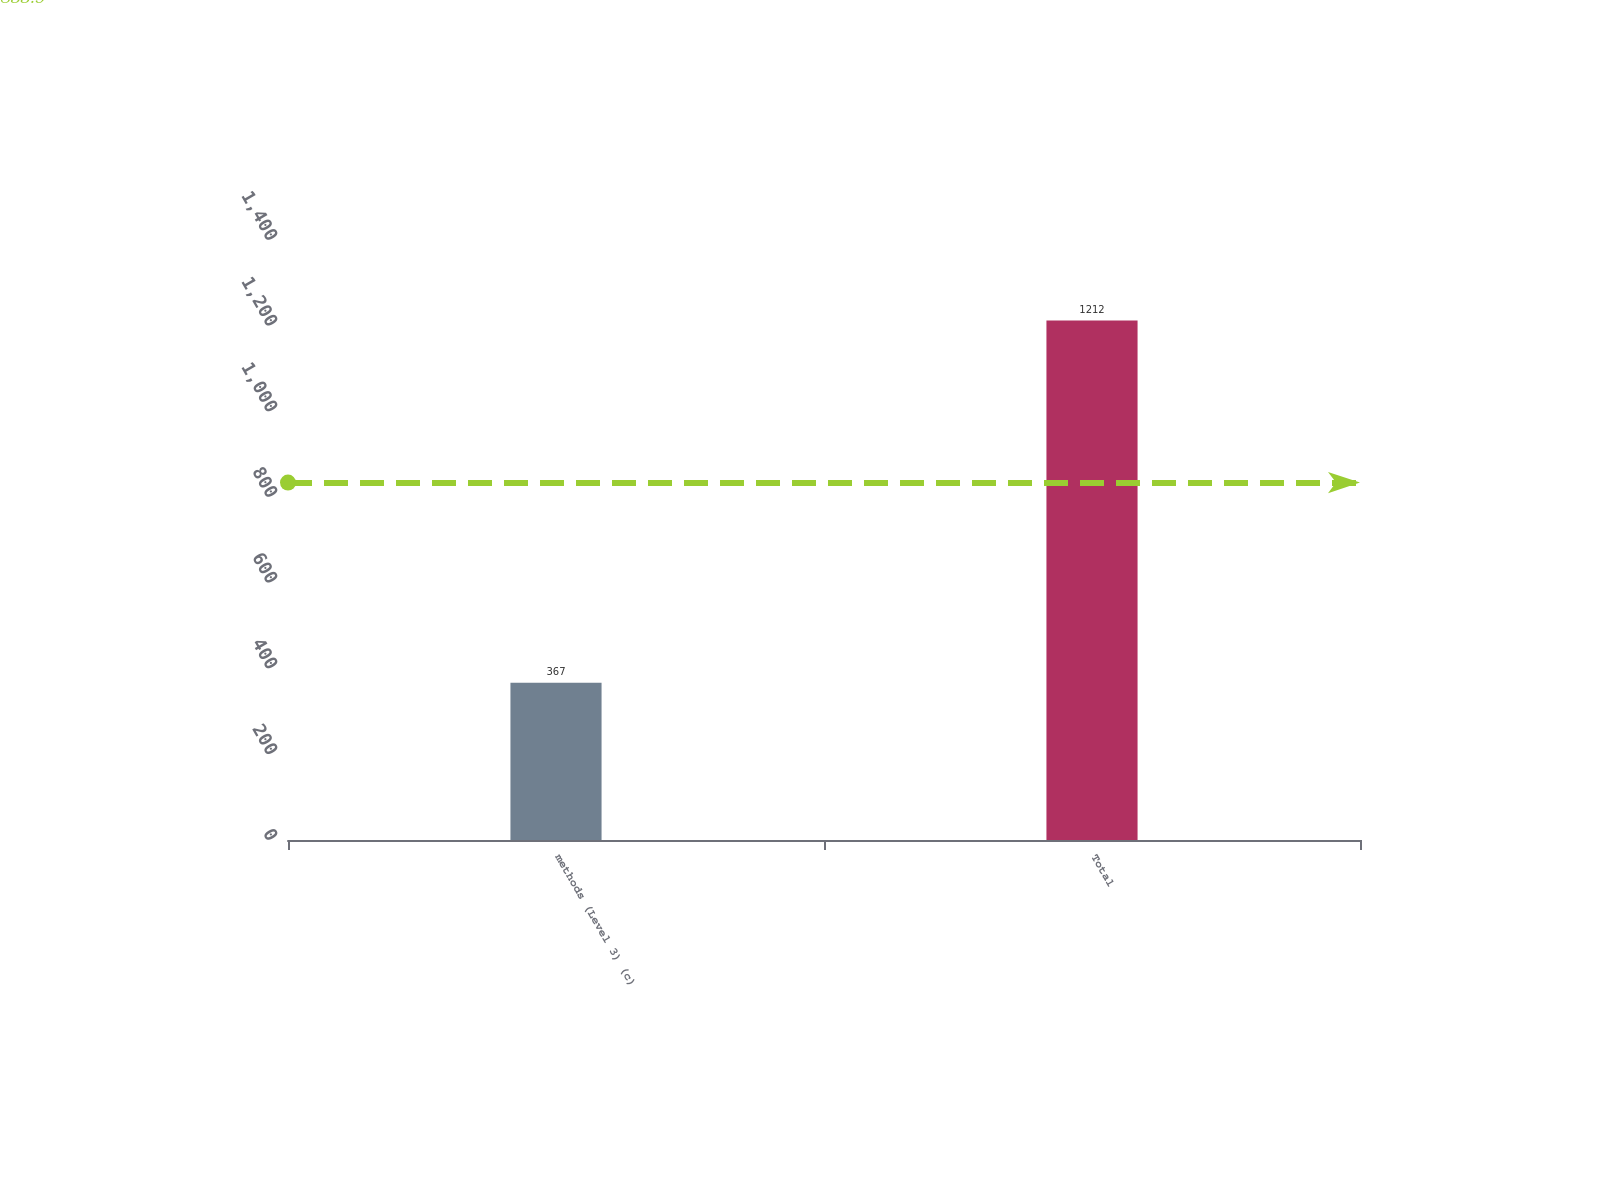<chart> <loc_0><loc_0><loc_500><loc_500><bar_chart><fcel>methods (Level 3) (c)<fcel>Total<nl><fcel>367<fcel>1212<nl></chart> 